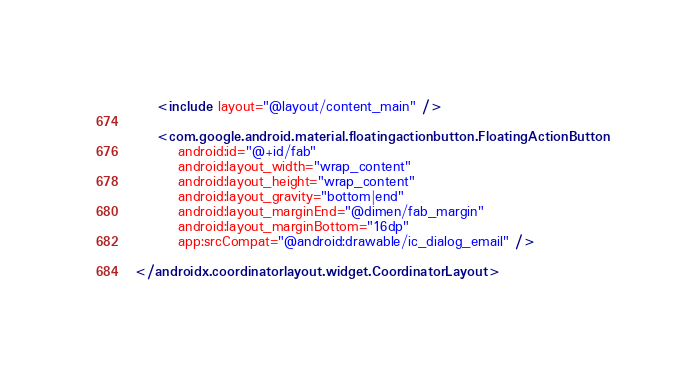<code> <loc_0><loc_0><loc_500><loc_500><_XML_>
    <include layout="@layout/content_main" />

    <com.google.android.material.floatingactionbutton.FloatingActionButton
        android:id="@+id/fab"
        android:layout_width="wrap_content"
        android:layout_height="wrap_content"
        android:layout_gravity="bottom|end"
        android:layout_marginEnd="@dimen/fab_margin"
        android:layout_marginBottom="16dp"
        app:srcCompat="@android:drawable/ic_dialog_email" />

</androidx.coordinatorlayout.widget.CoordinatorLayout></code> 